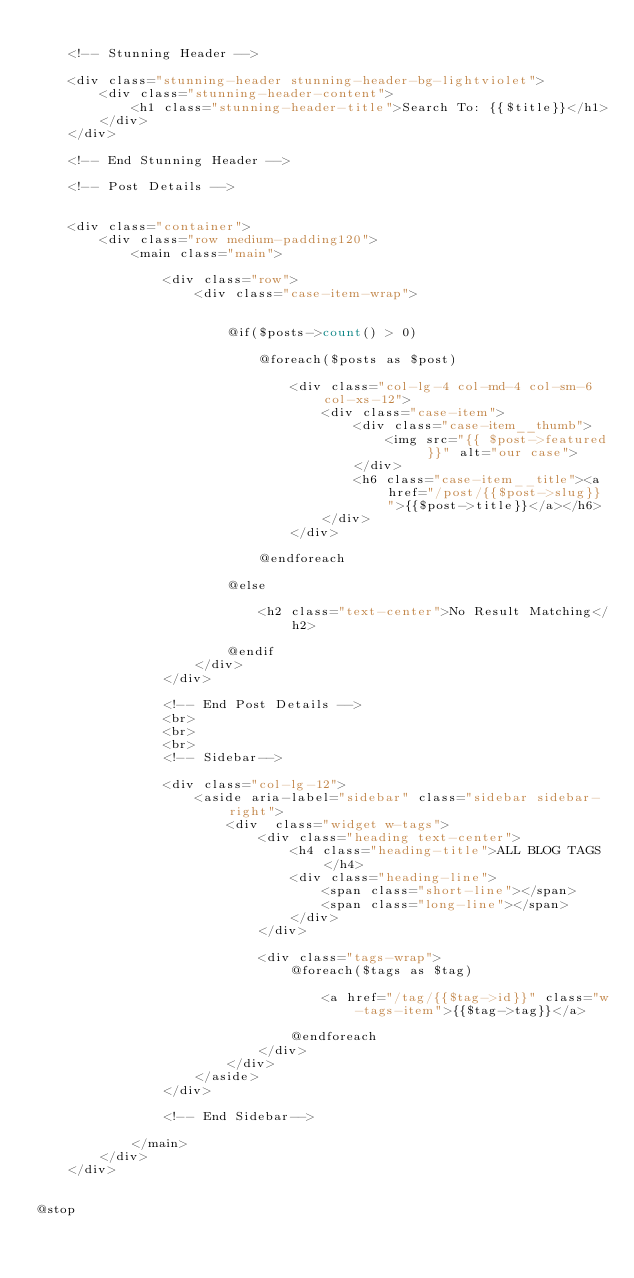Convert code to text. <code><loc_0><loc_0><loc_500><loc_500><_PHP_>
    <!-- Stunning Header -->

    <div class="stunning-header stunning-header-bg-lightviolet">
        <div class="stunning-header-content">
            <h1 class="stunning-header-title">Search To: {{$title}}</h1>
        </div>
    </div>

    <!-- End Stunning Header -->

    <!-- Post Details -->


    <div class="container">
        <div class="row medium-padding120">
            <main class="main">

                <div class="row">
                    <div class="case-item-wrap">


                        @if($posts->count() > 0)

                            @foreach($posts as $post)

                                <div class="col-lg-4 col-md-4 col-sm-6 col-xs-12">
                                    <div class="case-item">
                                        <div class="case-item__thumb">
                                            <img src="{{ $post->featured }}" alt="our case">
                                        </div>
                                        <h6 class="case-item__title"><a href="/post/{{$post->slug}}">{{$post->title}}</a></h6>
                                    </div>
                                </div>

                            @endforeach

                        @else

                            <h2 class="text-center">No Result Matching</h2>

                        @endif
                    </div>
                </div>

                <!-- End Post Details -->
                <br>
                <br>
                <br>
                <!-- Sidebar-->

                <div class="col-lg-12">
                    <aside aria-label="sidebar" class="sidebar sidebar-right">
                        <div  class="widget w-tags">
                            <div class="heading text-center">
                                <h4 class="heading-title">ALL BLOG TAGS</h4>
                                <div class="heading-line">
                                    <span class="short-line"></span>
                                    <span class="long-line"></span>
                                </div>
                            </div>

                            <div class="tags-wrap">
                                @foreach($tags as $tag)

                                    <a href="/tag/{{$tag->id}}" class="w-tags-item">{{$tag->tag}}</a>

                                @endforeach
                            </div>
                        </div>
                    </aside>
                </div>

                <!-- End Sidebar-->

            </main>
        </div>
    </div>


@stop</code> 